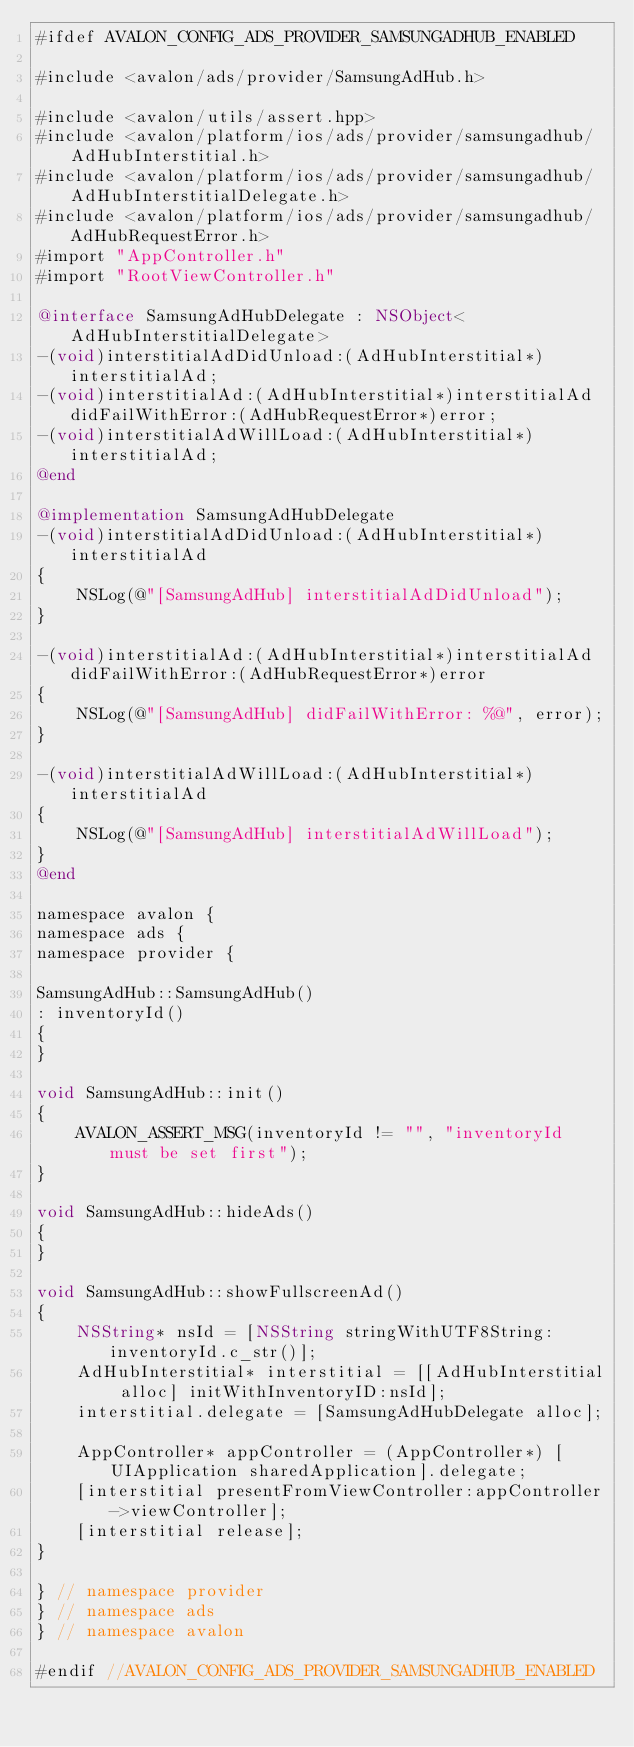Convert code to text. <code><loc_0><loc_0><loc_500><loc_500><_ObjectiveC_>#ifdef AVALON_CONFIG_ADS_PROVIDER_SAMSUNGADHUB_ENABLED

#include <avalon/ads/provider/SamsungAdHub.h>

#include <avalon/utils/assert.hpp>
#include <avalon/platform/ios/ads/provider/samsungadhub/AdHubInterstitial.h>
#include <avalon/platform/ios/ads/provider/samsungadhub/AdHubInterstitialDelegate.h>
#include <avalon/platform/ios/ads/provider/samsungadhub/AdHubRequestError.h>
#import "AppController.h"
#import "RootViewController.h"

@interface SamsungAdHubDelegate : NSObject<AdHubInterstitialDelegate>
-(void)interstitialAdDidUnload:(AdHubInterstitial*)interstitialAd;
-(void)interstitialAd:(AdHubInterstitial*)interstitialAd didFailWithError:(AdHubRequestError*)error;
-(void)interstitialAdWillLoad:(AdHubInterstitial*)interstitialAd;
@end

@implementation SamsungAdHubDelegate
-(void)interstitialAdDidUnload:(AdHubInterstitial*)interstitialAd
{
    NSLog(@"[SamsungAdHub] interstitialAdDidUnload");
}

-(void)interstitialAd:(AdHubInterstitial*)interstitialAd didFailWithError:(AdHubRequestError*)error
{
    NSLog(@"[SamsungAdHub] didFailWithError: %@", error);
}

-(void)interstitialAdWillLoad:(AdHubInterstitial*)interstitialAd
{
    NSLog(@"[SamsungAdHub] interstitialAdWillLoad");
}
@end

namespace avalon {
namespace ads {
namespace provider {

SamsungAdHub::SamsungAdHub()
: inventoryId()
{
}

void SamsungAdHub::init()
{
    AVALON_ASSERT_MSG(inventoryId != "", "inventoryId must be set first");
}

void SamsungAdHub::hideAds()
{
}

void SamsungAdHub::showFullscreenAd()
{
    NSString* nsId = [NSString stringWithUTF8String:inventoryId.c_str()];
    AdHubInterstitial* interstitial = [[AdHubInterstitial alloc] initWithInventoryID:nsId];
    interstitial.delegate = [SamsungAdHubDelegate alloc];

    AppController* appController = (AppController*) [UIApplication sharedApplication].delegate;
    [interstitial presentFromViewController:appController->viewController];
    [interstitial release];
}

} // namespace provider
} // namespace ads
} // namespace avalon

#endif //AVALON_CONFIG_ADS_PROVIDER_SAMSUNGADHUB_ENABLED
</code> 